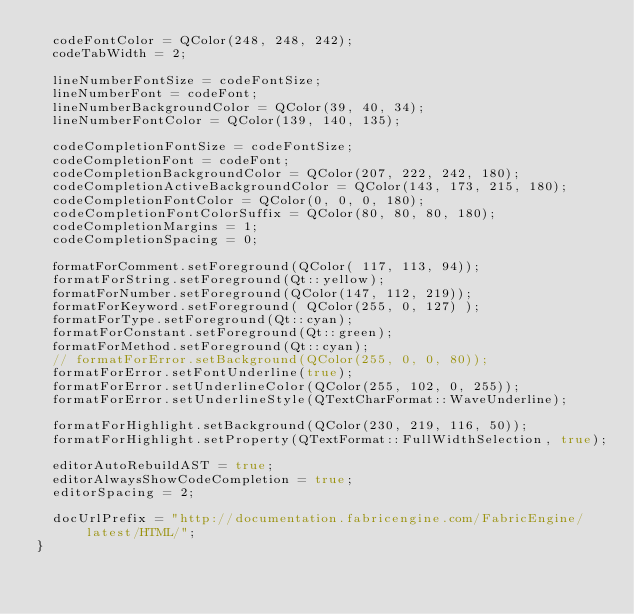Convert code to text. <code><loc_0><loc_0><loc_500><loc_500><_C++_>  codeFontColor = QColor(248, 248, 242);
  codeTabWidth = 2;

  lineNumberFontSize = codeFontSize;
  lineNumberFont = codeFont;
  lineNumberBackgroundColor = QColor(39, 40, 34);
  lineNumberFontColor = QColor(139, 140, 135);

  codeCompletionFontSize = codeFontSize;
  codeCompletionFont = codeFont;
  codeCompletionBackgroundColor = QColor(207, 222, 242, 180);
  codeCompletionActiveBackgroundColor = QColor(143, 173, 215, 180);
  codeCompletionFontColor = QColor(0, 0, 0, 180);
  codeCompletionFontColorSuffix = QColor(80, 80, 80, 180);
  codeCompletionMargins = 1;
  codeCompletionSpacing = 0;

  formatForComment.setForeground(QColor( 117, 113, 94));
  formatForString.setForeground(Qt::yellow);
  formatForNumber.setForeground(QColor(147, 112, 219));
  formatForKeyword.setForeground( QColor(255, 0, 127) );
  formatForType.setForeground(Qt::cyan);
  formatForConstant.setForeground(Qt::green);
  formatForMethod.setForeground(Qt::cyan);
  // formatForError.setBackground(QColor(255, 0, 0, 80));
  formatForError.setFontUnderline(true);
  formatForError.setUnderlineColor(QColor(255, 102, 0, 255));
  formatForError.setUnderlineStyle(QTextCharFormat::WaveUnderline);

  formatForHighlight.setBackground(QColor(230, 219, 116, 50));
  formatForHighlight.setProperty(QTextFormat::FullWidthSelection, true);

  editorAutoRebuildAST = true;
  editorAlwaysShowCodeCompletion = true;
  editorSpacing = 2;

  docUrlPrefix = "http://documentation.fabricengine.com/FabricEngine/latest/HTML/";
}
</code> 